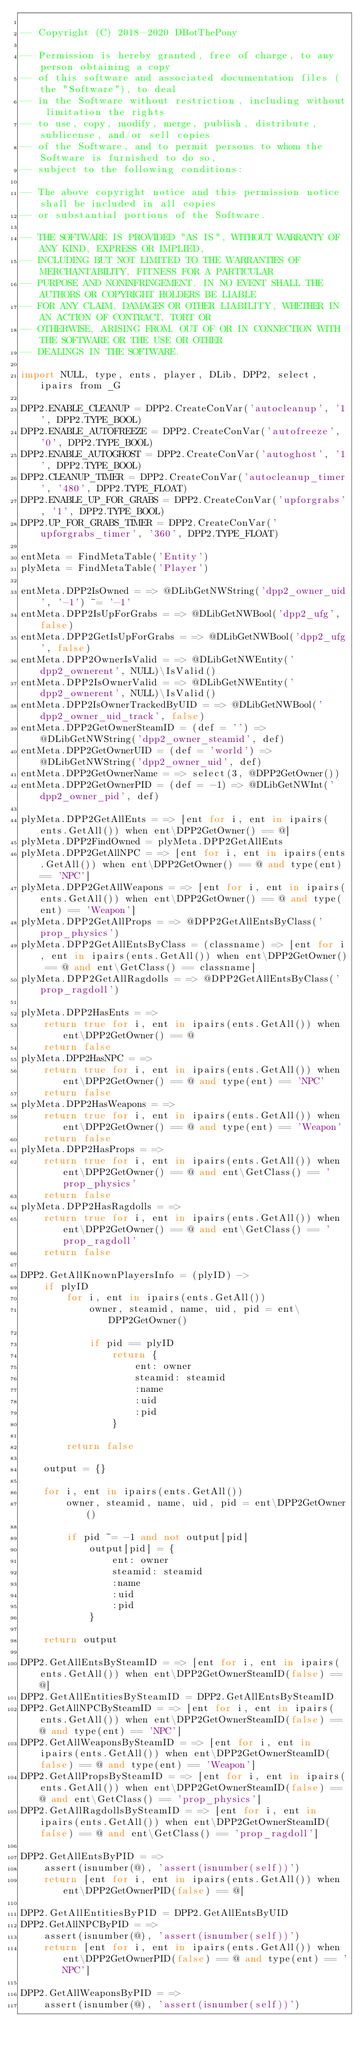Convert code to text. <code><loc_0><loc_0><loc_500><loc_500><_MoonScript_>
-- Copyright (C) 2018-2020 DBotThePony

-- Permission is hereby granted, free of charge, to any person obtaining a copy
-- of this software and associated documentation files (the "Software"), to deal
-- in the Software without restriction, including without limitation the rights
-- to use, copy, modify, merge, publish, distribute, sublicense, and/or sell copies
-- of the Software, and to permit persons to whom the Software is furnished to do so,
-- subject to the following conditions:

-- The above copyright notice and this permission notice shall be included in all copies
-- or substantial portions of the Software.

-- THE SOFTWARE IS PROVIDED "AS IS", WITHOUT WARRANTY OF ANY KIND, EXPRESS OR IMPLIED,
-- INCLUDING BUT NOT LIMITED TO THE WARRANTIES OF MERCHANTABILITY, FITNESS FOR A PARTICULAR
-- PURPOSE AND NONINFRINGEMENT. IN NO EVENT SHALL THE AUTHORS OR COPYRIGHT HOLDERS BE LIABLE
-- FOR ANY CLAIM, DAMAGES OR OTHER LIABILITY, WHETHER IN AN ACTION OF CONTRACT, TORT OR
-- OTHERWISE, ARISING FROM, OUT OF OR IN CONNECTION WITH THE SOFTWARE OR THE USE OR OTHER
-- DEALINGS IN THE SOFTWARE.

import NULL, type, ents, player, DLib, DPP2, select, ipairs from _G

DPP2.ENABLE_CLEANUP = DPP2.CreateConVar('autocleanup', '1', DPP2.TYPE_BOOL)
DPP2.ENABLE_AUTOFREEZE = DPP2.CreateConVar('autofreeze', '0', DPP2.TYPE_BOOL)
DPP2.ENABLE_AUTOGHOST = DPP2.CreateConVar('autoghost', '1', DPP2.TYPE_BOOL)
DPP2.CLEANUP_TIMER = DPP2.CreateConVar('autocleanup_timer', '480', DPP2.TYPE_FLOAT)
DPP2.ENABLE_UP_FOR_GRABS = DPP2.CreateConVar('upforgrabs', '1', DPP2.TYPE_BOOL)
DPP2.UP_FOR_GRABS_TIMER = DPP2.CreateConVar('upforgrabs_timer', '360', DPP2.TYPE_FLOAT)

entMeta = FindMetaTable('Entity')
plyMeta = FindMetaTable('Player')

entMeta.DPP2IsOwned = => @DLibGetNWString('dpp2_owner_uid', '-1') ~= '-1'
entMeta.DPP2IsUpForGrabs = => @DLibGetNWBool('dpp2_ufg', false)
entMeta.DPP2GetIsUpForGrabs = => @DLibGetNWBool('dpp2_ufg', false)
entMeta.DPP2OwnerIsValid = => @DLibGetNWEntity('dpp2_ownerent', NULL)\IsValid()
entMeta.DPP2IsOwnerValid = => @DLibGetNWEntity('dpp2_ownerent', NULL)\IsValid()
entMeta.DPP2IsOwnerTrackedByUID = => @DLibGetNWBool('dpp2_owner_uid_track', false)
entMeta.DPP2GetOwnerSteamID = (def = '') => @DLibGetNWString('dpp2_owner_steamid', def)
entMeta.DPP2GetOwnerUID = (def = 'world') => @DLibGetNWString('dpp2_owner_uid', def)
entMeta.DPP2GetOwnerName = => select(3, @DPP2GetOwner())
entMeta.DPP2GetOwnerPID = (def = -1) => @DLibGetNWInt('dpp2_owner_pid', def)

plyMeta.DPP2GetAllEnts = => [ent for i, ent in ipairs(ents.GetAll()) when ent\DPP2GetOwner() == @]
plyMeta.DPP2FindOwned = plyMeta.DPP2GetAllEnts
plyMeta.DPP2GetAllNPC = => [ent for i, ent in ipairs(ents.GetAll()) when ent\DPP2GetOwner() == @ and type(ent) == 'NPC']
plyMeta.DPP2GetAllWeapons = => [ent for i, ent in ipairs(ents.GetAll()) when ent\DPP2GetOwner() == @ and type(ent) == 'Weapon']
plyMeta.DPP2GetAllProps = => @DPP2GetAllEntsByClass('prop_physics')
plyMeta.DPP2GetAllEntsByClass = (classname) => [ent for i, ent in ipairs(ents.GetAll()) when ent\DPP2GetOwner() == @ and ent\GetClass() == classname]
plyMeta.DPP2GetAllRagdolls = => @DPP2GetAllEntsByClass('prop_ragdoll')

plyMeta.DPP2HasEnts = =>
	return true for i, ent in ipairs(ents.GetAll()) when ent\DPP2GetOwner() == @
	return false
plyMeta.DPP2HasNPC = =>
	return true for i, ent in ipairs(ents.GetAll()) when ent\DPP2GetOwner() == @ and type(ent) == 'NPC'
	return false
plyMeta.DPP2HasWeapons = =>
	return true for i, ent in ipairs(ents.GetAll()) when ent\DPP2GetOwner() == @ and type(ent) == 'Weapon'
	return false
plyMeta.DPP2HasProps = =>
	return true for i, ent in ipairs(ents.GetAll()) when ent\DPP2GetOwner() == @ and ent\GetClass() == 'prop_physics'
	return false
plyMeta.DPP2HasRagdolls = =>
	return true for i, ent in ipairs(ents.GetAll()) when ent\DPP2GetOwner() == @ and ent\GetClass() == 'prop_ragdoll'
	return false

DPP2.GetAllKnownPlayersInfo = (plyID) ->
	if plyID
		for i, ent in ipairs(ents.GetAll())
			owner, steamid, name, uid, pid = ent\DPP2GetOwner()

			if pid == plyID
				return {
					ent: owner
					steamid: steamid
					:name
					:uid
					:pid
				}

		return false

	output = {}

	for i, ent in ipairs(ents.GetAll())
		owner, steamid, name, uid, pid = ent\DPP2GetOwner()

		if pid ~= -1 and not output[pid]
			output[pid] = {
				ent: owner
				steamid: steamid
				:name
				:uid
				:pid
			}

	return output

DPP2.GetAllEntsBySteamID = => [ent for i, ent in ipairs(ents.GetAll()) when ent\DPP2GetOwnerSteamID(false) == @]
DPP2.GetAllEntitiesBySteamID = DPP2.GetAllEntsBySteamID
DPP2.GetAllNPCBySteamID = => [ent for i, ent in ipairs(ents.GetAll()) when ent\DPP2GetOwnerSteamID(false) == @ and type(ent) == 'NPC']
DPP2.GetAllWeaponsBySteamID = => [ent for i, ent in ipairs(ents.GetAll()) when ent\DPP2GetOwnerSteamID(false) == @ and type(ent) == 'Weapon']
DPP2.GetAllPropsBySteamID = => [ent for i, ent in ipairs(ents.GetAll()) when ent\DPP2GetOwnerSteamID(false) == @ and ent\GetClass() == 'prop_physics']
DPP2.GetAllRagdollsBySteamID = => [ent for i, ent in ipairs(ents.GetAll()) when ent\DPP2GetOwnerSteamID(false) == @ and ent\GetClass() == 'prop_ragdoll']

DPP2.GetAllEntsByPID = =>
	assert(isnumber(@), 'assert(isnumber(self))')
	return [ent for i, ent in ipairs(ents.GetAll()) when ent\DPP2GetOwnerPID(false) == @]

DPP2.GetAllEntitiesByPID = DPP2.GetAllEntsByUID
DPP2.GetAllNPCByPID = =>
	assert(isnumber(@), 'assert(isnumber(self))')
	return [ent for i, ent in ipairs(ents.GetAll()) when ent\DPP2GetOwnerPID(false) == @ and type(ent) == 'NPC']

DPP2.GetAllWeaponsByPID = =>
	assert(isnumber(@), 'assert(isnumber(self))')</code> 